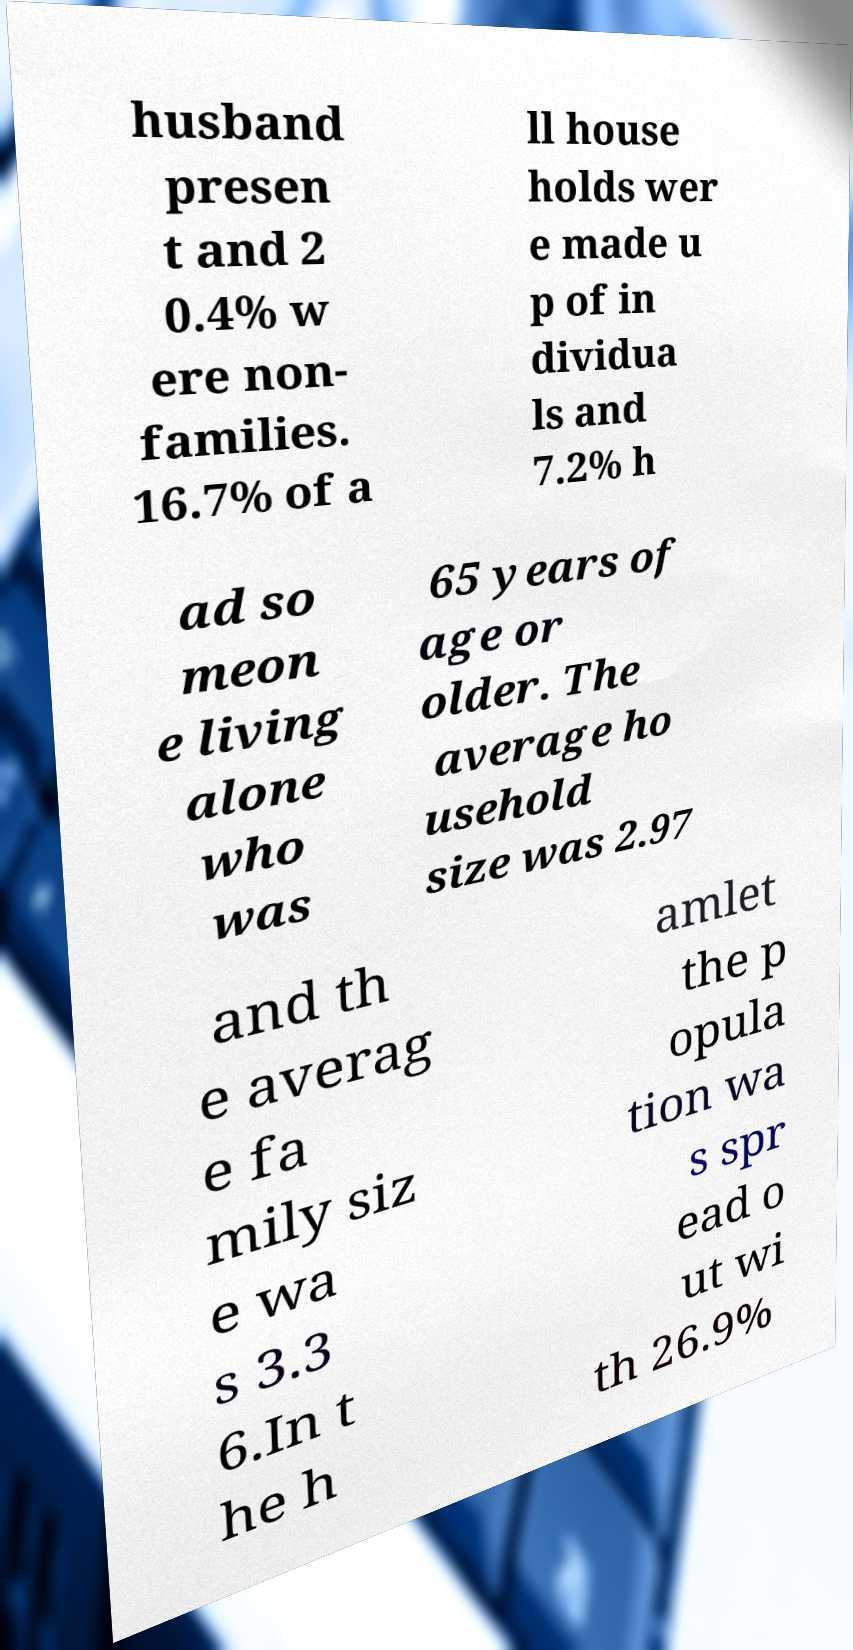What messages or text are displayed in this image? I need them in a readable, typed format. husband presen t and 2 0.4% w ere non- families. 16.7% of a ll house holds wer e made u p of in dividua ls and 7.2% h ad so meon e living alone who was 65 years of age or older. The average ho usehold size was 2.97 and th e averag e fa mily siz e wa s 3.3 6.In t he h amlet the p opula tion wa s spr ead o ut wi th 26.9% 